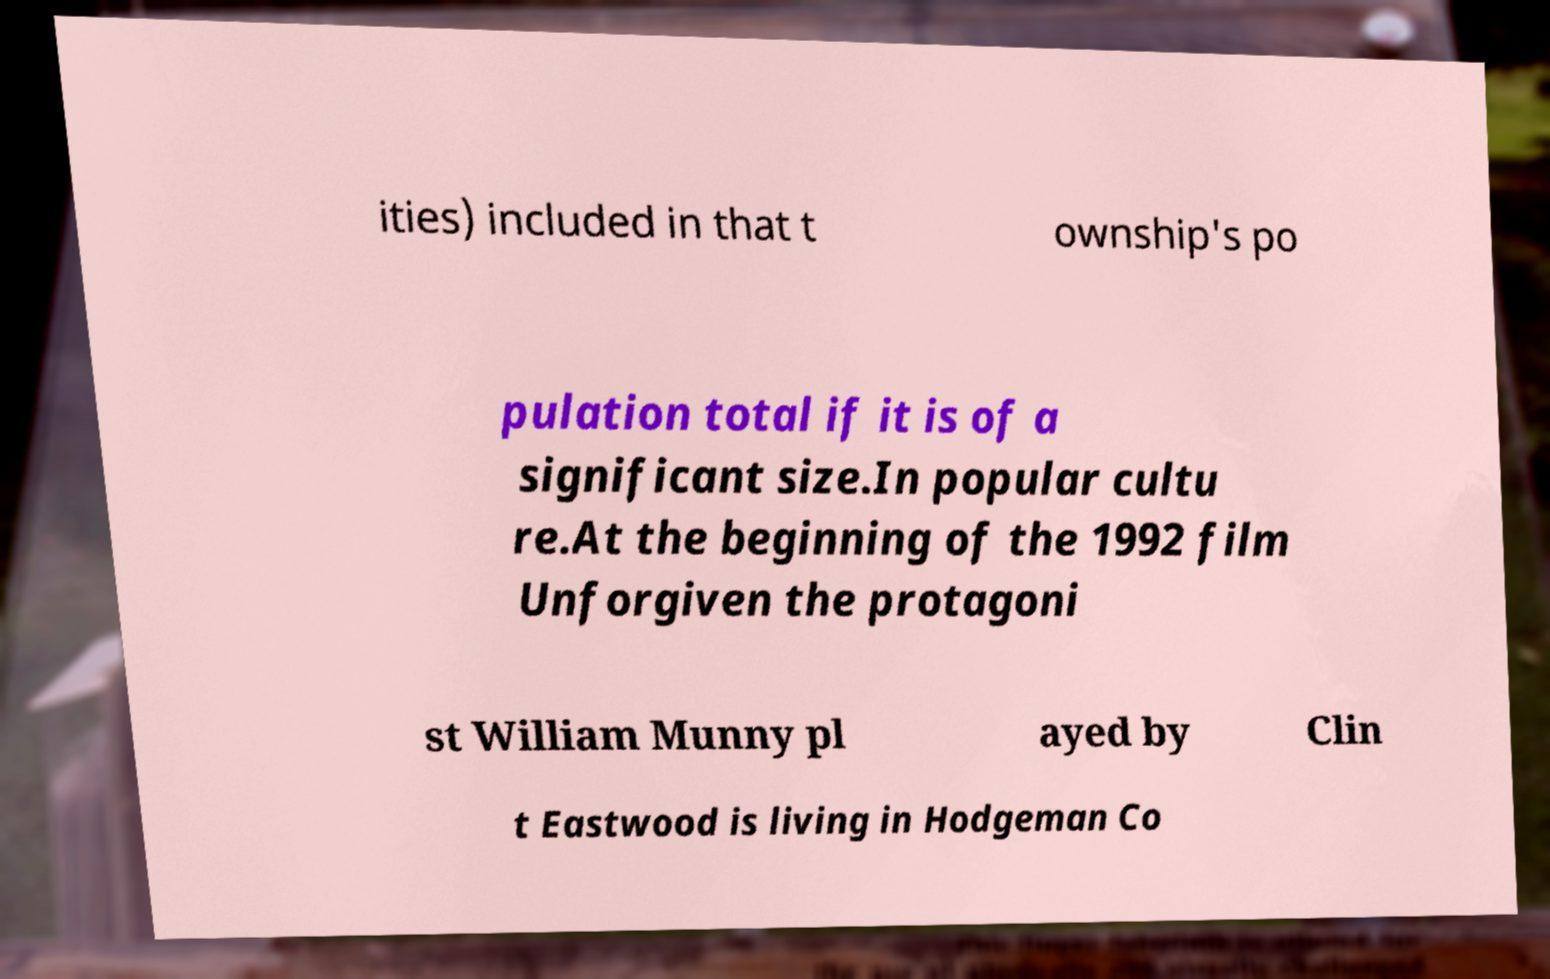Could you assist in decoding the text presented in this image and type it out clearly? ities) included in that t ownship's po pulation total if it is of a significant size.In popular cultu re.At the beginning of the 1992 film Unforgiven the protagoni st William Munny pl ayed by Clin t Eastwood is living in Hodgeman Co 